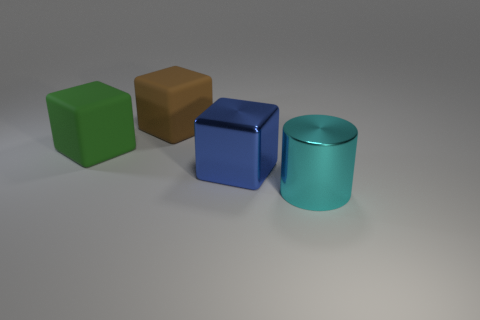Add 4 green rubber cubes. How many objects exist? 8 Subtract all cylinders. How many objects are left? 3 Subtract all tiny brown matte objects. Subtract all big green rubber cubes. How many objects are left? 3 Add 1 large cyan cylinders. How many large cyan cylinders are left? 2 Add 2 big purple shiny things. How many big purple shiny things exist? 2 Subtract 1 green cubes. How many objects are left? 3 